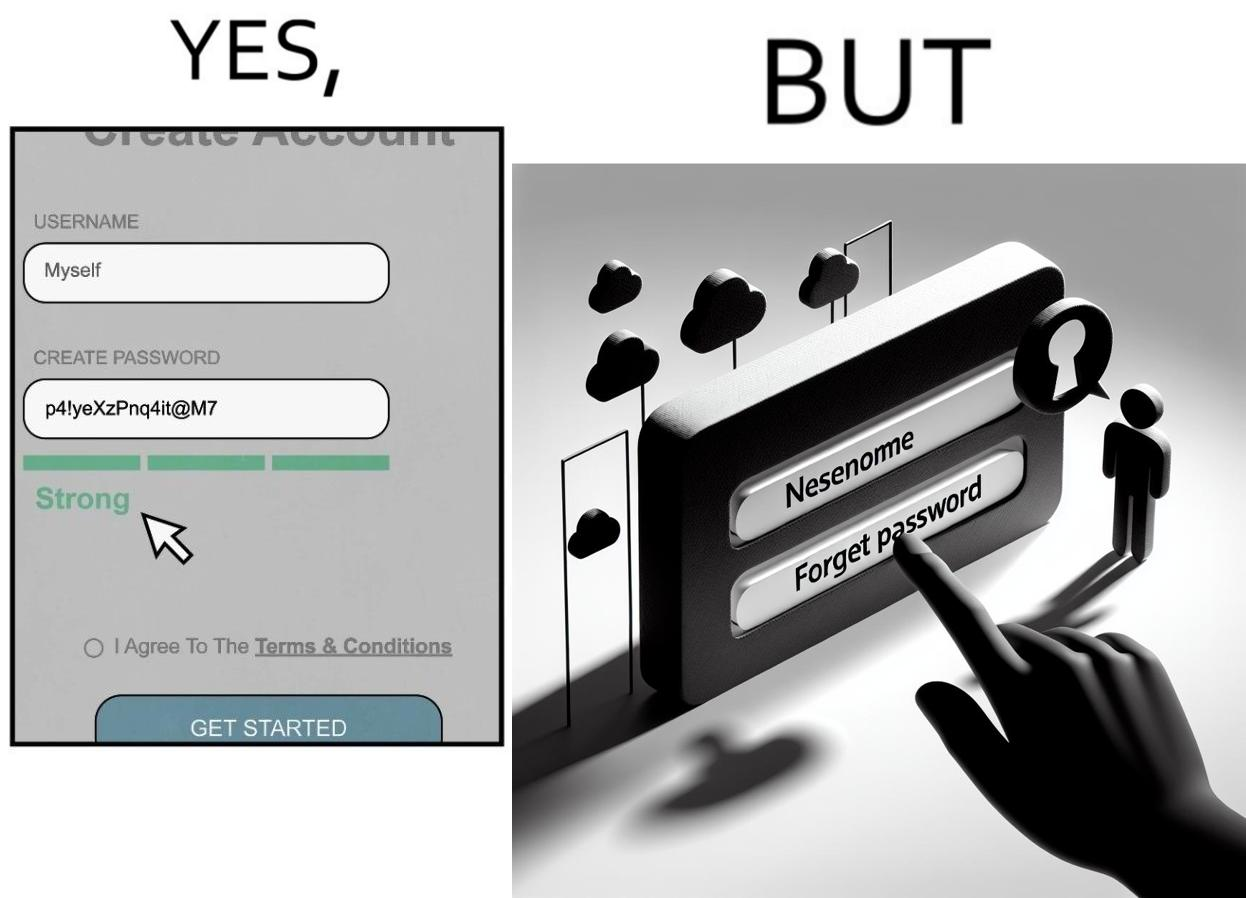What does this image depict? The image is ironic, because people set such a strong passwords for their accounts that they even forget the password and need to reset them 